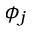Convert formula to latex. <formula><loc_0><loc_0><loc_500><loc_500>\phi _ { j }</formula> 